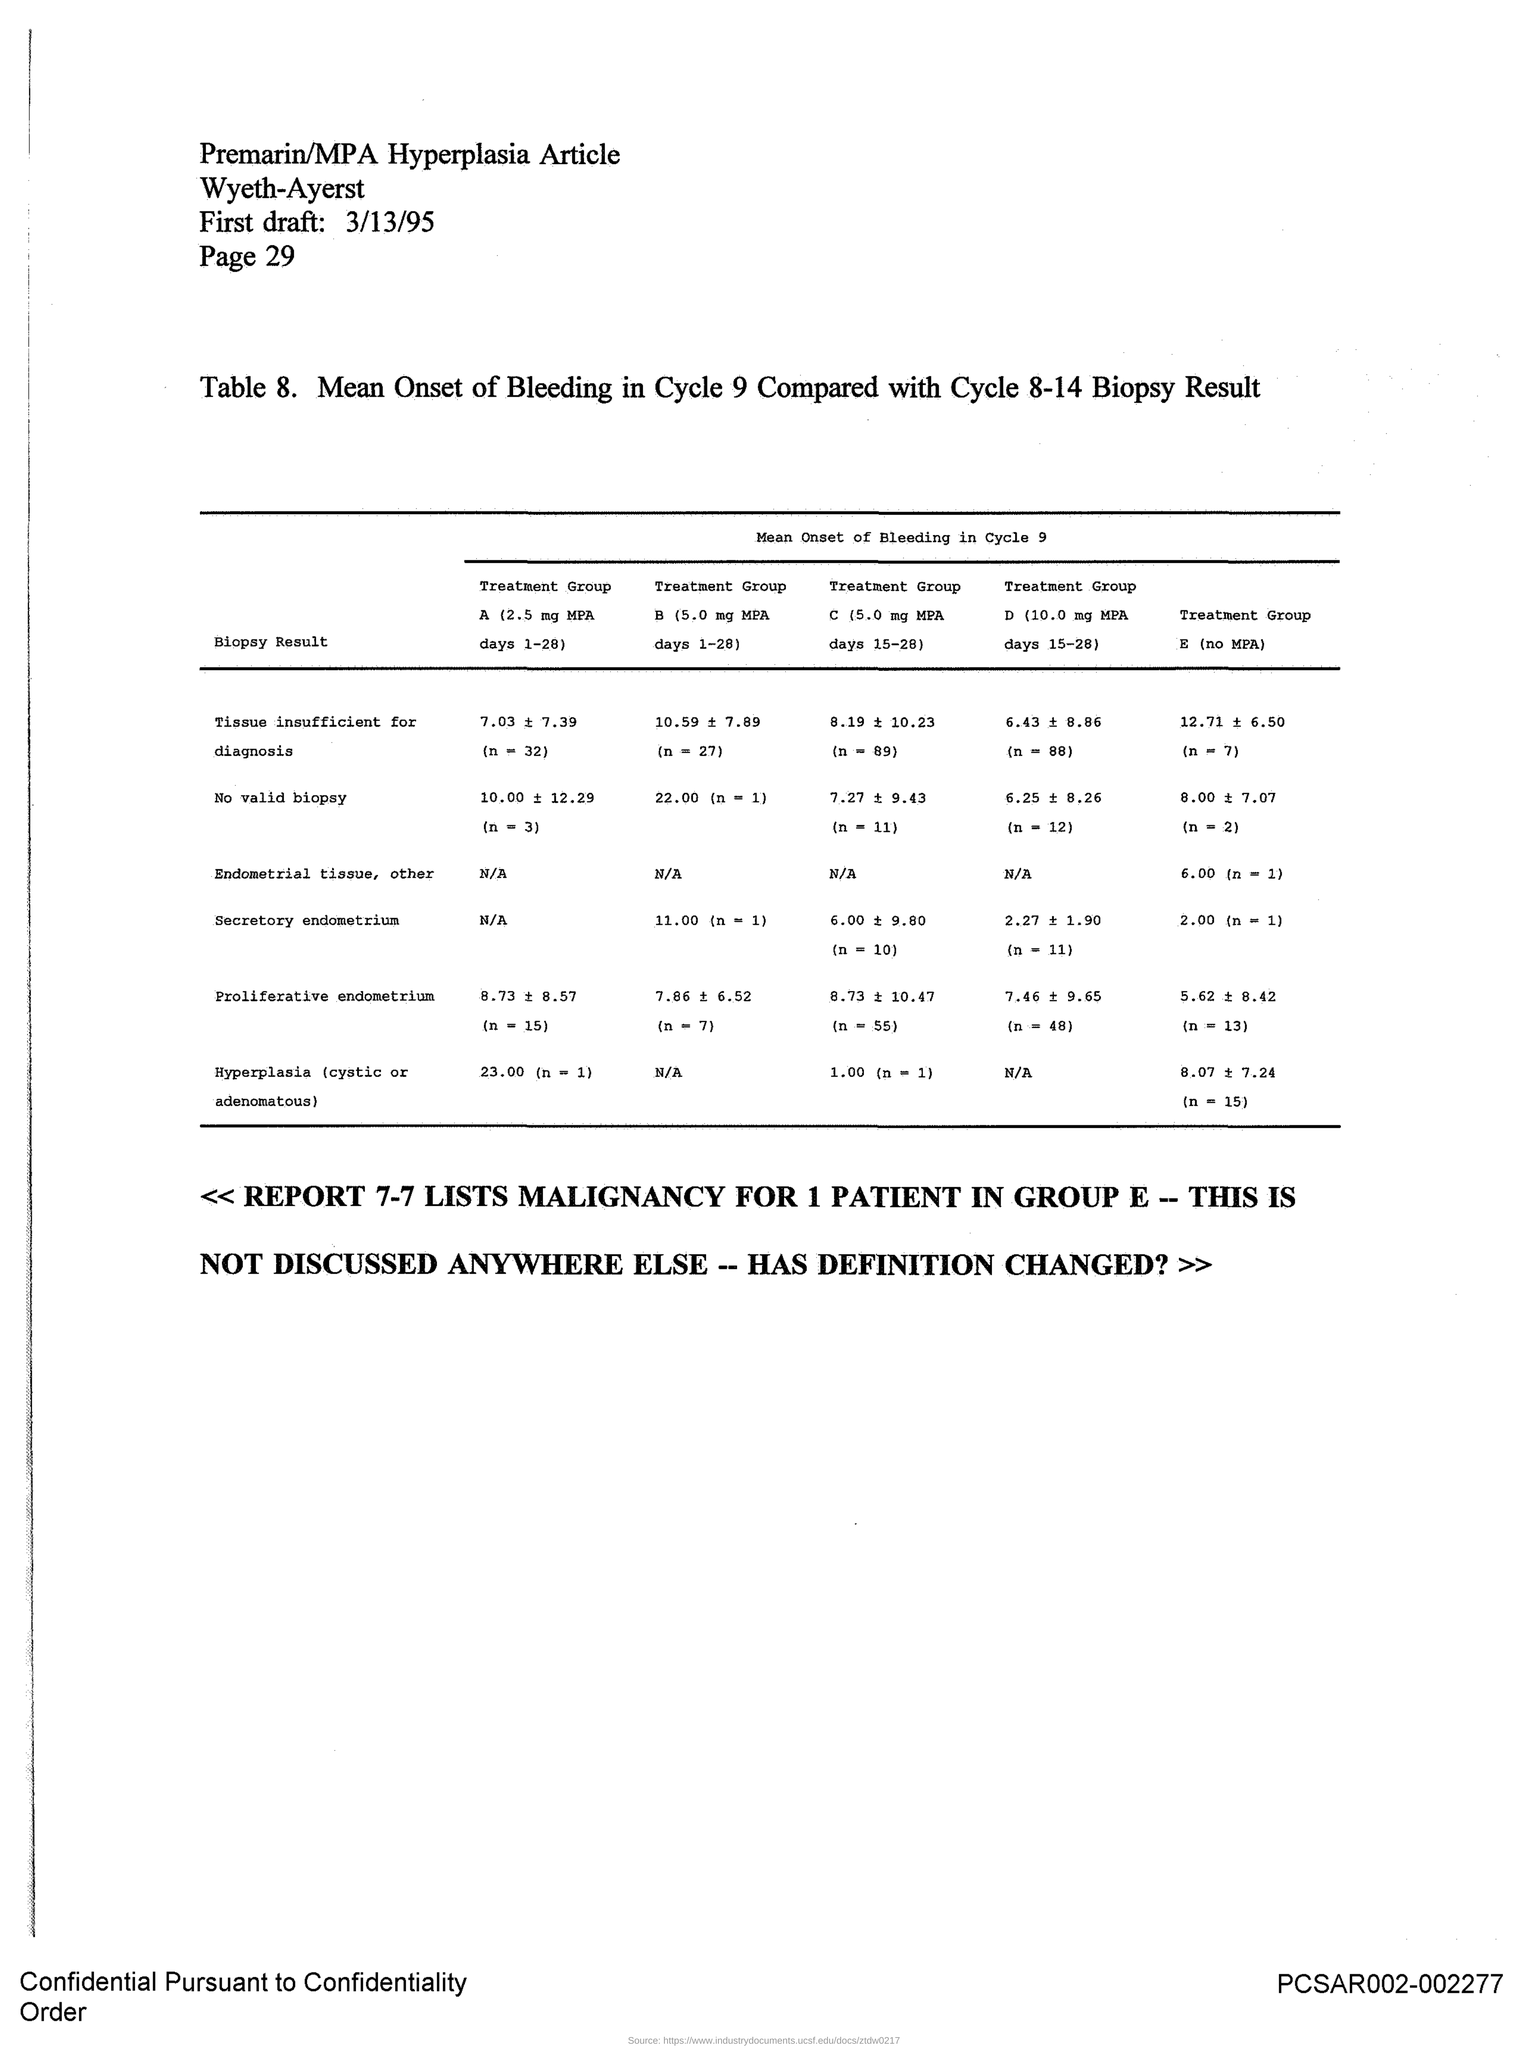Which article is mentioned in the document?
Ensure brevity in your answer.  Premarin/MPA Hyperplasia Article. What is the page no mentioned in this document?
Your answer should be very brief. 29. What is the first draft date given in the document?
Give a very brief answer. 3/13/95. 